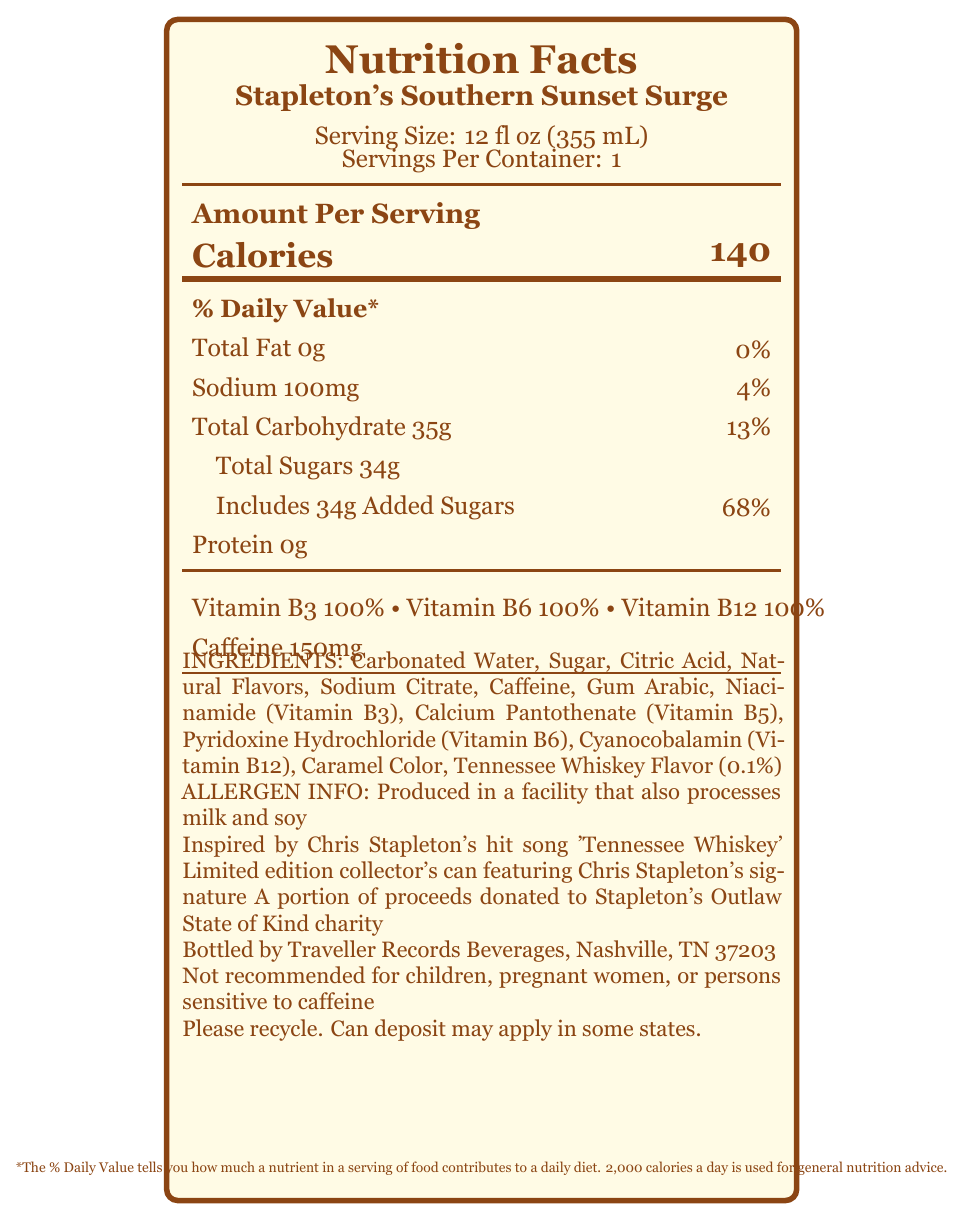what is the serving size of Stapleton's Southern Sunset Surge? The serving size is explicitly mentioned as "Serving Size: 12 fl oz (355 mL)" in the document.
Answer: 12 fl oz (355 mL) how many calories are in a serving of Stapleton's Southern Sunset Surge? The document states "Calories 140" which specifies the number of calories per serving.
Answer: 140 what is the amount of caffeine in Stapleton's Southern Sunset Surge? The document states "Caffeine 150mg" in the listed nutrient information.
Answer: 150mg what percentage of daily value is provided by the added sugars in the drink? The document notes "Includes 34g Added Sugars" with a corresponding daily value percentage of 68%.
Answer: 68% who is the manufacturer of Stapleton's Southern Sunset Surge? The manufacturer's information is provided as "Bottled by Traveller Records Beverages, Nashville, TN 37203".
Answer: Traveller Records Beverages, Nashville, TN 37203 what is the total carbohydrate content in Stapleton's Southern Sunset Surge? The total carbohydrate content is listed as "Total Carbohydrate 35g".
Answer: 35g how many servings are in each container of Stapleton's Southern Sunset Surge? The document states "Servings Per Container: 1".
Answer: 1 which vitamin is not listed in the document? A. Vitamin B3 B. Vitamin B6 C. Vitamin B12 D. Vitamin C Vitamins B3, B6, and B12 are listed, while Vitamin C is not mentioned in the document.
Answer: D. Vitamin C which of the following ingredients is found in the smallest quantity? A. Caffeine B. Sodium Citrate C. Gum Arabic D. Tennessee Whiskey Flavor Tennessee Whiskey Flavor is mentioned as containing 0.1%, which is likely the smallest listed ingredient.
Answer: D. Tennessee Whiskey Flavor what is the percentage of daily value for sodium in the drink? A. 0% B. 4% C. 10% D. 18% The percentage daily value for sodium is given as 4%.
Answer: B. 4% is Stapleton's Southern Sunset Surge suitable for children or pregnant women? The document includes a disclaimer stating "Not recommended for children, pregnant women, or persons sensitive to caffeine."
Answer: No summarize the main information provided in the document about Stapleton's Southern Sunset Surge. This summary encapsulates key points about the energy drink's nutritional content, ingredients, manufacturer, and special notes about its limited edition and charity donations.
Answer: Stapleton's Southern Sunset Surge is a limited edition Chris Stapleton-themed energy drink with a serving size of 12 fl oz, containing 140 calories, 150mg of caffeine, and vitamins B3, B6, and B12. It includes 68% of the daily value for added sugars and 4% for sodium. Ingredients include carbonated water, sugar, and Tennessee Whiskey Flavor. It is produced by Traveller Records Beverages in Nashville and is not recommended for children or pregnant women. A portion of proceeds goes to Chris Stapleton's charity. how much protein is in a serving of Stapleton's Southern Sunset Surge? The document states "Protein 0g," indicating no protein content.
Answer: 0g what song inspired Stapleton's Southern Sunset Surge? One of the special notes in the document states that the drink is "Inspired by Chris Stapleton's hit song 'Tennessee Whiskey'".
Answer: 'Tennessee Whiskey' does the document specify the amount of calcium in Stapleton's Southern Sunset Surge? The document does not provide any information regarding the calcium content in the drink.
Answer: Not enough information 